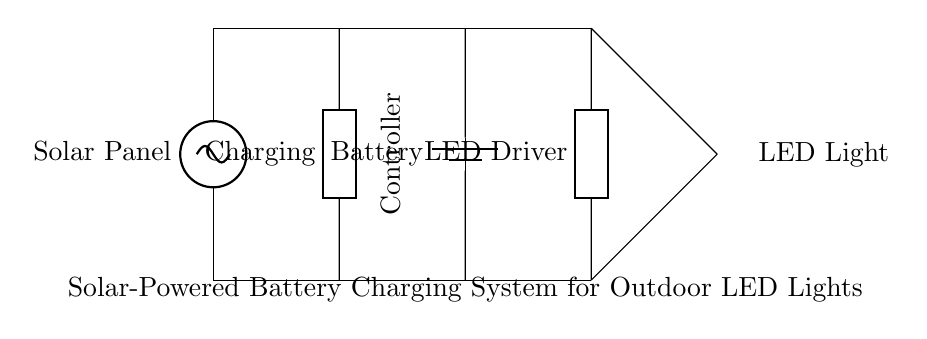What is the first component in the circuit? The first component in the circuit is the solar panel, which is drawn at the top left position and marked clearly.
Answer: Solar Panel What is the role of the charging controller? The charging controller is responsible for regulating the charging of the battery, ensuring that it receives the correct voltage and current from the solar panel.
Answer: Regulating battery charging How many components are connected in the circuit? The circuit consists of five main components, including the solar panel, charging controller, battery, LED driver, and LED light.
Answer: Five What direction does current flow from the solar panel? Current flows from the solar panel down towards the charging controller and further through the circuit components.
Answer: Downwards What type of circuit is this example? This is a solar-powered charging circuit specifically designed for outdoor LED lights, leveraging renewable energy for operation.
Answer: Solar-powered charging circuit What component is used to convert the battery's output for the LED light? The LED driver converts the battery's output to a suitable form for the LED light, allowing it to function properly.
Answer: LED Driver 